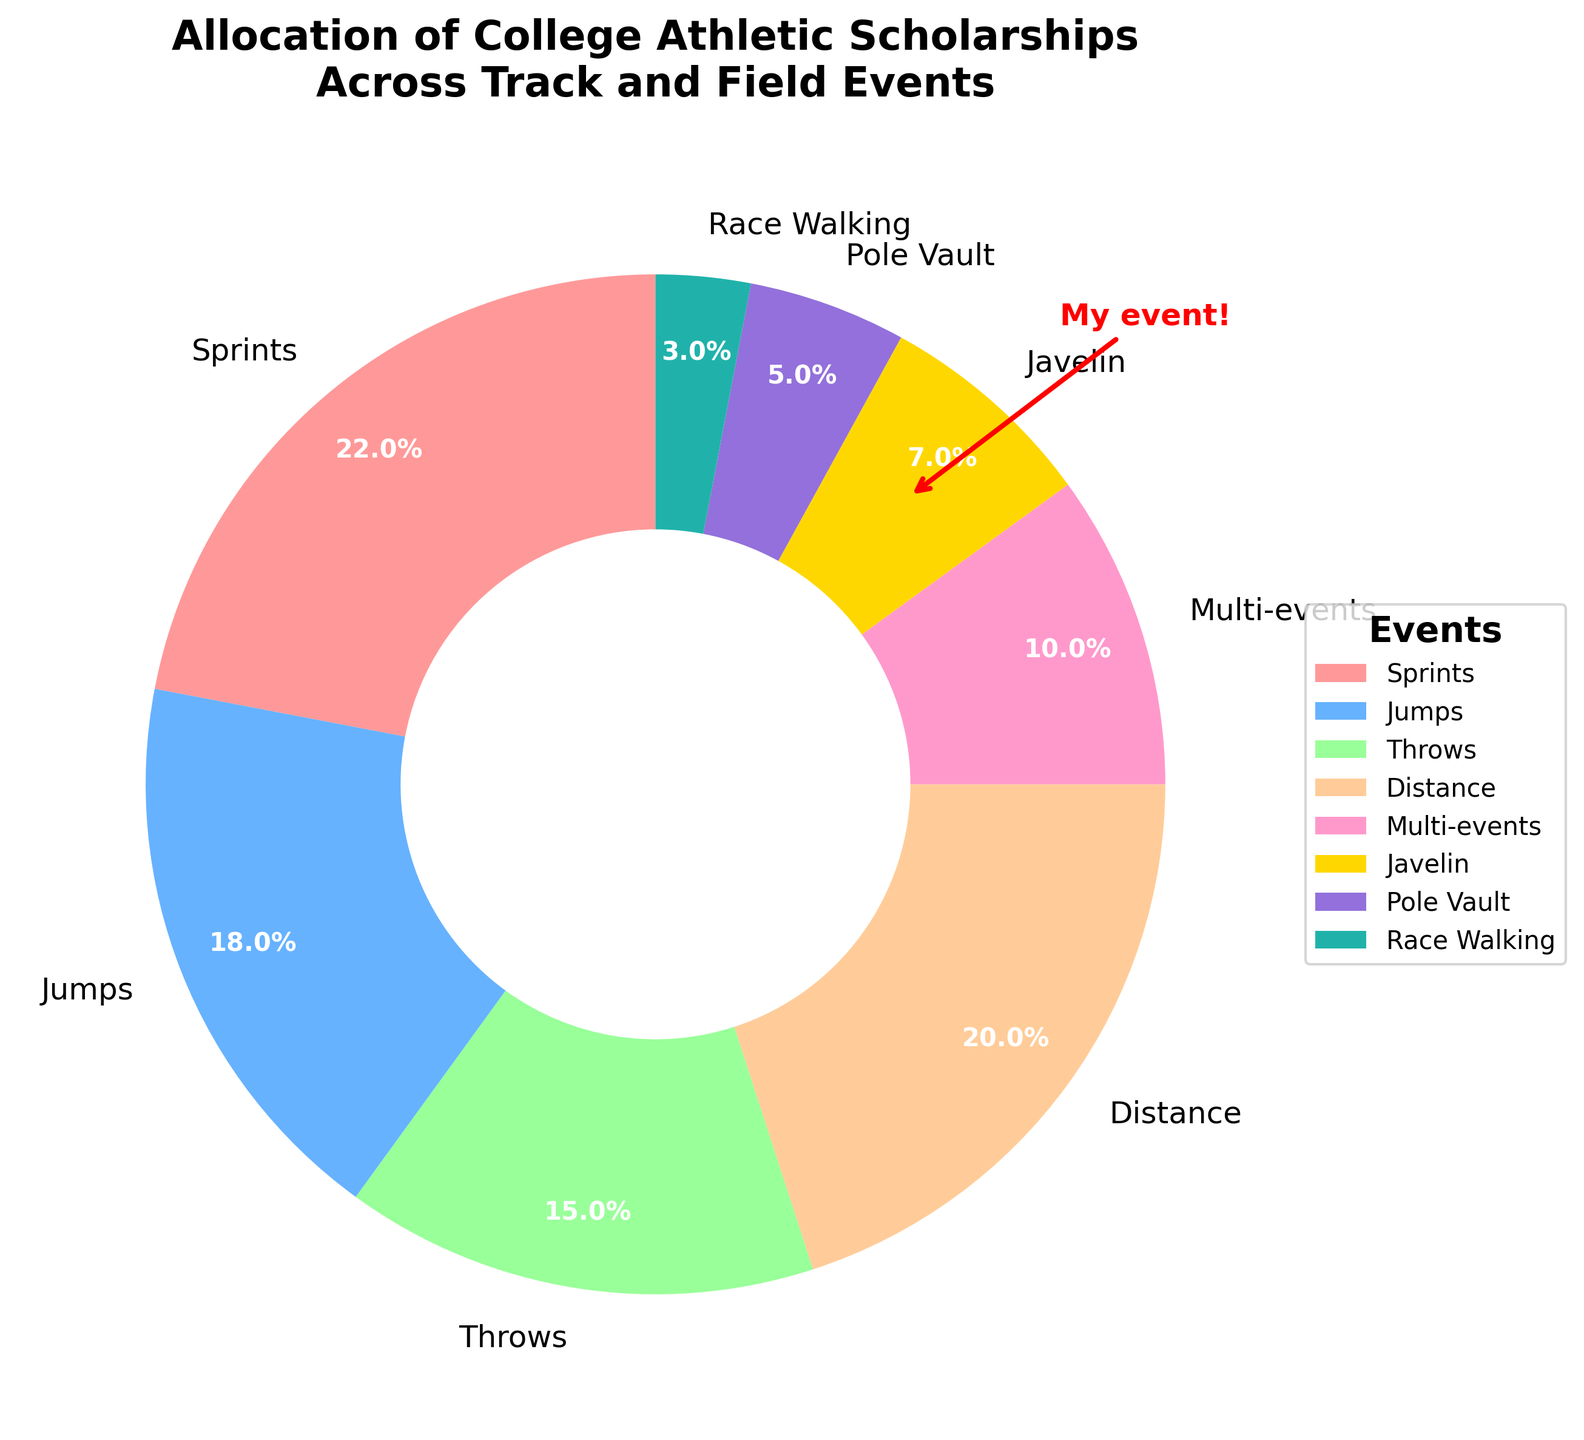Which event has the highest percentage of college athletic scholarships? Looking at the pie chart, the segment representing Sprints is the largest.
Answer: Sprints Which two events combined have the smallest percentage of scholarships? By adding the percentages of the two smallest segments, Race Walking (3%) and Pole Vault (5%) sum to 8%, which is the smallest combined portion.
Answer: Race Walking and Pole Vault What is the total percentage of scholarships allocated to field events (Jumps, Throws, Pole Vault, Javelin)? Adding the percentages for Jumps (18%), Throws (15%), Pole Vault (5%), and Javelin (7%) gives 18 + 15 + 5 + 7 = 45.
Answer: 45% How does the percentage of scholarships for Javelin compare to those for Multi-events? The pie chart shows that Javelin has a 7% allocation, while Multi-events have 10%. Since 10% is greater than 7%, Multi-events have a higher percentage.
Answer: Multi-events have more What fraction of the scholarships does the Distance event receive compared to the total? The Distance event has 20% of the total scholarships. Since the whole pie represents 100%, the fraction is 20/100, which simplifies to 1/5.
Answer: 1/5 How much more percentage of scholarships does Sprints receive compared to Throws? Sprints have 22% and Throws have 15%. The difference is calculated as 22 - 15 = 7%.
Answer: 7% more Which color represents the Javelin event in the pie chart? Following the colors outlined in the code, and seeing the placement in the pie chart, Javelin is represented by a golden yellow color.
Answer: Golden yellow What is the percentage difference between the scholarships for Distance and Throws? Distance has 20% and Throws have 15%. The percentage difference is calculated as 20 - 15 = 5%.
Answer: 5% If the quotas were to be doubled, what would be the new percentage for Distance? Doubling the current percentage for Distance (20%) results in 20 * 2 = 40%.
Answer: 40% What is the overall percentage allocated to running events (Sprints, Distance, Race Walking)? Adding the percentages for Sprints (22%), Distance (20%), and Race Walking (3%), gives 22 + 20 + 3 = 45%.
Answer: 45% 